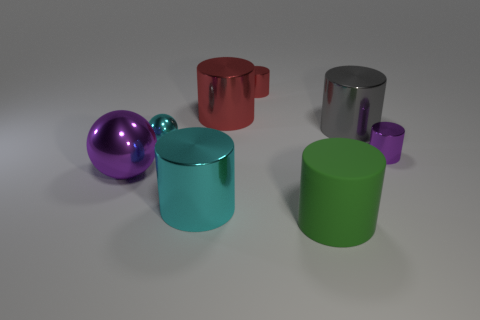Subtract all big cyan metal cylinders. How many cylinders are left? 5 Add 1 cyan metallic things. How many objects exist? 9 Subtract all green cylinders. How many cylinders are left? 5 Subtract 5 cylinders. How many cylinders are left? 1 Subtract all green spheres. How many cyan cylinders are left? 1 Subtract all large gray metallic cylinders. Subtract all small yellow rubber things. How many objects are left? 7 Add 5 small objects. How many small objects are left? 8 Add 3 spheres. How many spheres exist? 5 Subtract 0 gray blocks. How many objects are left? 8 Subtract all cylinders. How many objects are left? 2 